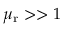Convert formula to latex. <formula><loc_0><loc_0><loc_500><loc_500>\mu _ { r } > > 1</formula> 